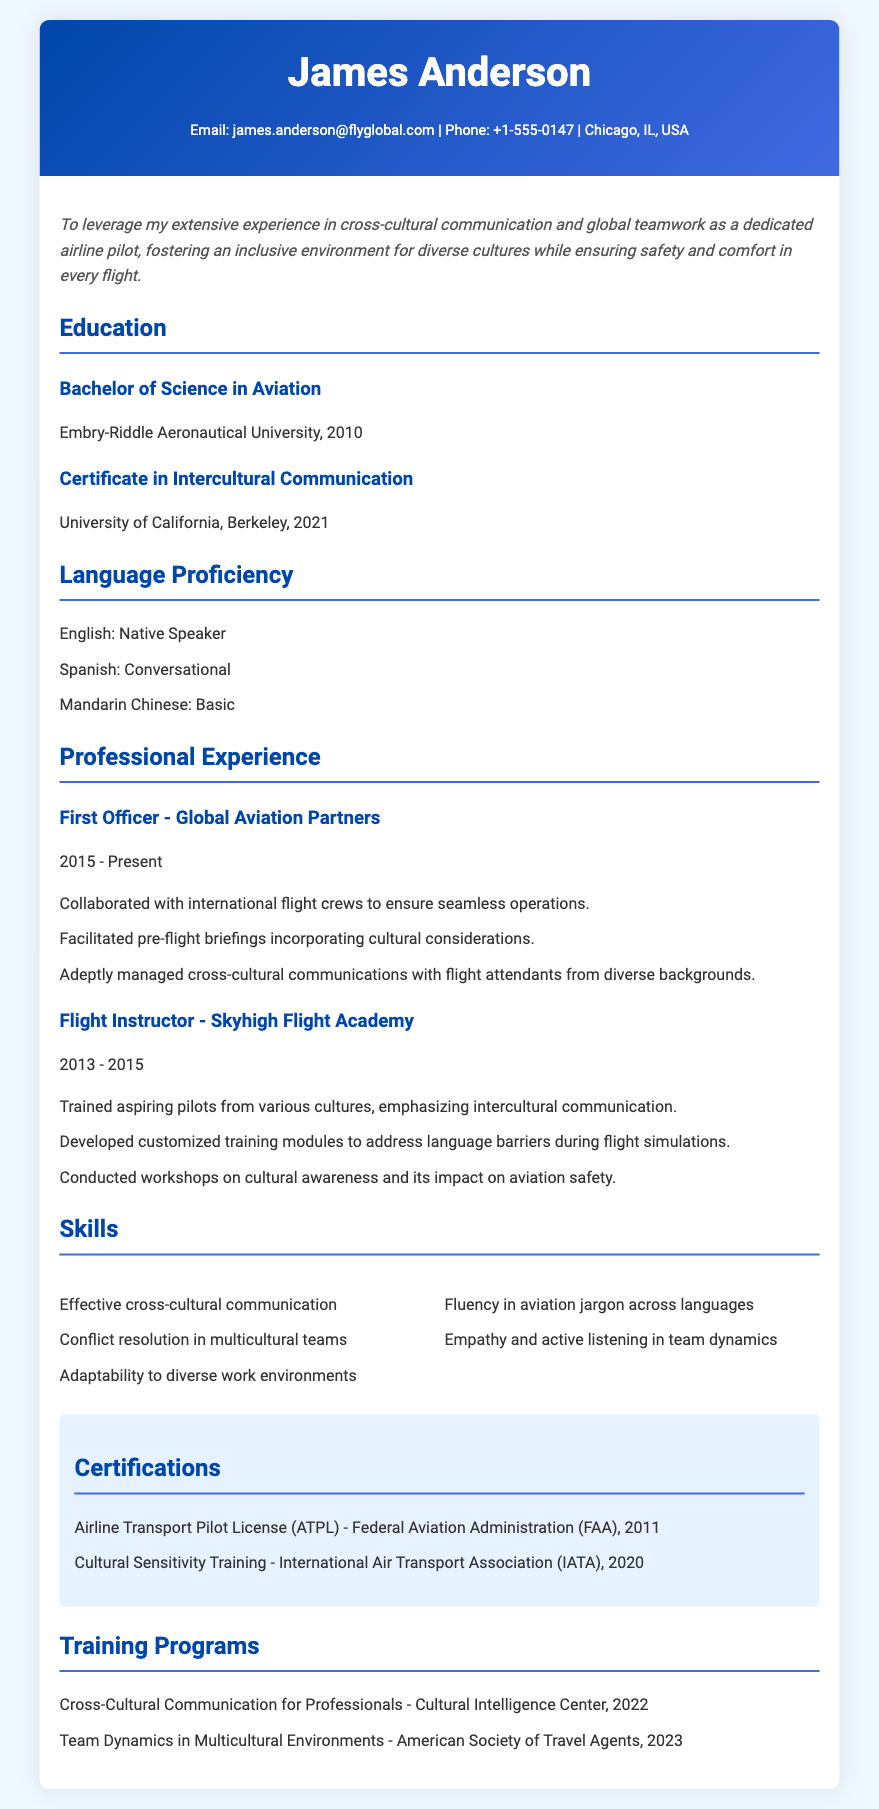what is the degree obtained by James Anderson? The degree obtained is listed under Education in the document, which states "Bachelor of Science in Aviation".
Answer: Bachelor of Science in Aviation what year did James Anderson complete his Certificate in Intercultural Communication? The document provides the year for this certificate under Education, which is 2021.
Answer: 2021 how many languages does James Anderson list proficiency in? The document mentions three languages under Language Proficiency.
Answer: Three which company did James Anderson work for as a First Officer? This information is found in the Professional Experience section where he is listed as a First Officer for Global Aviation Partners.
Answer: Global Aviation Partners what type of training did James Anderson receive from the IATA? This certification is mentioned under Certifications in the document, indicating he completed "Cultural Sensitivity Training".
Answer: Cultural Sensitivity Training which training program did James Anderson attend in 2023? The document lists training programs under a specific section, revealing that he attended "Team Dynamics in Multicultural Environments" in that year.
Answer: Team Dynamics in Multicultural Environments what is the main objective that James Anderson aims to achieve in his role as a pilot? The objective clearly states his aim, which is fostering an inclusive environment for diverse cultures while ensuring safety and comfort in every flight.
Answer: Foster an inclusive environment for diverse cultures what is one of the skills highlighted in the Skills section? The Skills section lists "Effective cross-cultural communication" as one of the skills James possesses.
Answer: Effective cross-cultural communication how long did James Anderson work as a Flight Instructor? The document states the duration of his role as a Flight Instructor from 2013 to 2015, which can be determined as two years.
Answer: Two years 